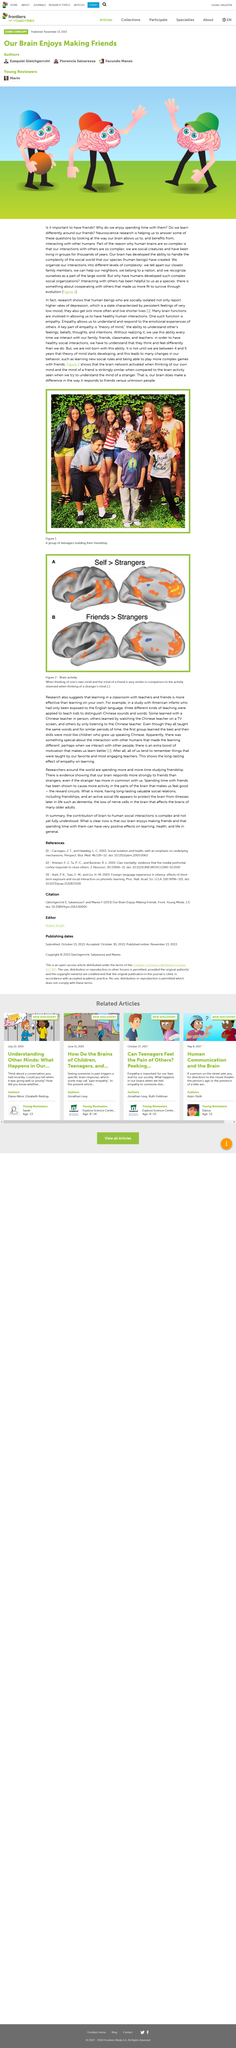Give some essential details in this illustration. It is through organizing our interactions into different levels of complexity that we are able to effectively navigate the world around us. Neuro Human brains are complex due to our complex social interactions with others, which have been ongoing for thousands of years. 